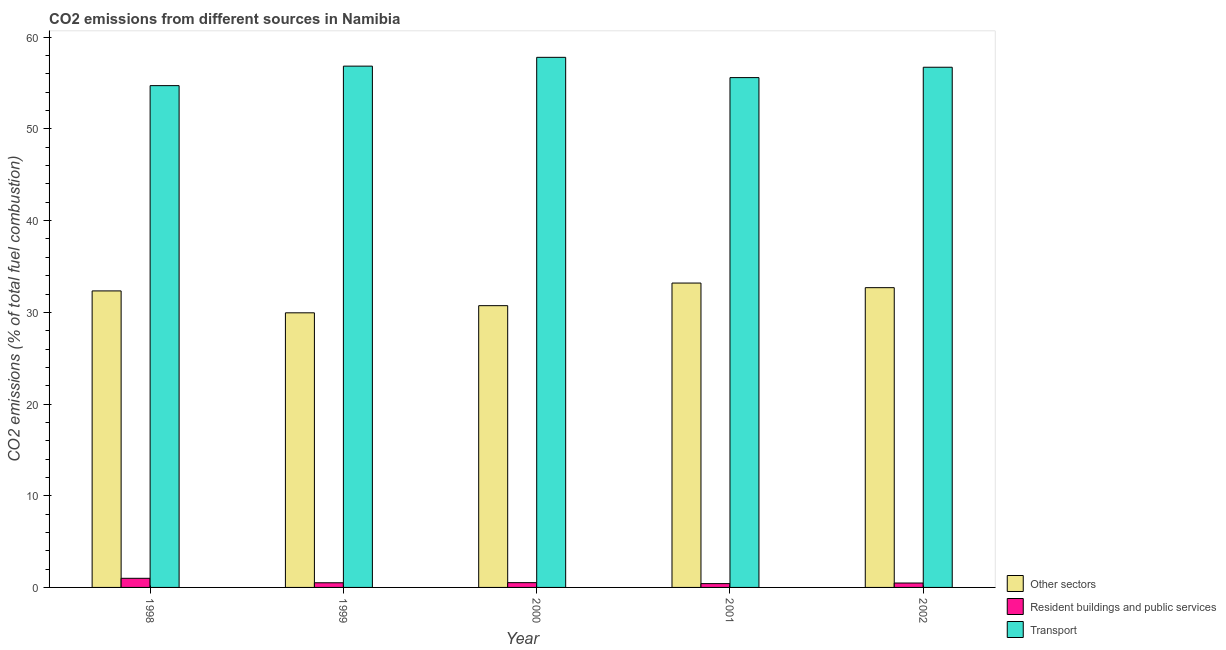How many groups of bars are there?
Provide a succinct answer. 5. Are the number of bars per tick equal to the number of legend labels?
Offer a very short reply. Yes. Are the number of bars on each tick of the X-axis equal?
Your answer should be compact. Yes. How many bars are there on the 2nd tick from the left?
Offer a very short reply. 3. What is the label of the 3rd group of bars from the left?
Your response must be concise. 2000. In how many cases, is the number of bars for a given year not equal to the number of legend labels?
Ensure brevity in your answer.  0. What is the percentage of co2 emissions from transport in 2001?
Keep it short and to the point. 55.6. Across all years, what is the maximum percentage of co2 emissions from transport?
Ensure brevity in your answer.  57.81. Across all years, what is the minimum percentage of co2 emissions from transport?
Give a very brief answer. 54.73. What is the total percentage of co2 emissions from transport in the graph?
Provide a succinct answer. 281.72. What is the difference between the percentage of co2 emissions from resident buildings and public services in 2001 and that in 2002?
Your answer should be compact. -0.07. What is the difference between the percentage of co2 emissions from transport in 1999 and the percentage of co2 emissions from other sectors in 1998?
Provide a short and direct response. 2.13. What is the average percentage of co2 emissions from other sectors per year?
Make the answer very short. 31.78. In how many years, is the percentage of co2 emissions from other sectors greater than 28 %?
Provide a short and direct response. 5. What is the ratio of the percentage of co2 emissions from resident buildings and public services in 2000 to that in 2002?
Make the answer very short. 1.08. Is the difference between the percentage of co2 emissions from resident buildings and public services in 1999 and 2000 greater than the difference between the percentage of co2 emissions from other sectors in 1999 and 2000?
Make the answer very short. No. What is the difference between the highest and the second highest percentage of co2 emissions from other sectors?
Ensure brevity in your answer.  0.5. What is the difference between the highest and the lowest percentage of co2 emissions from transport?
Make the answer very short. 3.09. In how many years, is the percentage of co2 emissions from other sectors greater than the average percentage of co2 emissions from other sectors taken over all years?
Keep it short and to the point. 3. Is the sum of the percentage of co2 emissions from resident buildings and public services in 1998 and 1999 greater than the maximum percentage of co2 emissions from transport across all years?
Keep it short and to the point. Yes. What does the 3rd bar from the left in 2002 represents?
Provide a succinct answer. Transport. What does the 3rd bar from the right in 2002 represents?
Provide a short and direct response. Other sectors. How many bars are there?
Your answer should be very brief. 15. Are the values on the major ticks of Y-axis written in scientific E-notation?
Provide a short and direct response. No. What is the title of the graph?
Give a very brief answer. CO2 emissions from different sources in Namibia. What is the label or title of the Y-axis?
Ensure brevity in your answer.  CO2 emissions (% of total fuel combustion). What is the CO2 emissions (% of total fuel combustion) in Other sectors in 1998?
Your answer should be very brief. 32.34. What is the CO2 emissions (% of total fuel combustion) in Resident buildings and public services in 1998?
Give a very brief answer. 1. What is the CO2 emissions (% of total fuel combustion) of Transport in 1998?
Ensure brevity in your answer.  54.73. What is the CO2 emissions (% of total fuel combustion) in Other sectors in 1999?
Provide a succinct answer. 29.95. What is the CO2 emissions (% of total fuel combustion) of Resident buildings and public services in 1999?
Offer a terse response. 0.51. What is the CO2 emissions (% of total fuel combustion) in Transport in 1999?
Give a very brief answer. 56.85. What is the CO2 emissions (% of total fuel combustion) in Other sectors in 2000?
Offer a terse response. 30.73. What is the CO2 emissions (% of total fuel combustion) in Resident buildings and public services in 2000?
Your answer should be compact. 0.52. What is the CO2 emissions (% of total fuel combustion) of Transport in 2000?
Keep it short and to the point. 57.81. What is the CO2 emissions (% of total fuel combustion) of Other sectors in 2001?
Give a very brief answer. 33.2. What is the CO2 emissions (% of total fuel combustion) of Resident buildings and public services in 2001?
Offer a terse response. 0.41. What is the CO2 emissions (% of total fuel combustion) in Transport in 2001?
Make the answer very short. 55.6. What is the CO2 emissions (% of total fuel combustion) in Other sectors in 2002?
Offer a very short reply. 32.69. What is the CO2 emissions (% of total fuel combustion) in Resident buildings and public services in 2002?
Your answer should be very brief. 0.48. What is the CO2 emissions (% of total fuel combustion) in Transport in 2002?
Make the answer very short. 56.73. Across all years, what is the maximum CO2 emissions (% of total fuel combustion) of Other sectors?
Offer a terse response. 33.2. Across all years, what is the maximum CO2 emissions (% of total fuel combustion) in Resident buildings and public services?
Ensure brevity in your answer.  1. Across all years, what is the maximum CO2 emissions (% of total fuel combustion) of Transport?
Your response must be concise. 57.81. Across all years, what is the minimum CO2 emissions (% of total fuel combustion) in Other sectors?
Your response must be concise. 29.95. Across all years, what is the minimum CO2 emissions (% of total fuel combustion) in Resident buildings and public services?
Your response must be concise. 0.41. Across all years, what is the minimum CO2 emissions (% of total fuel combustion) in Transport?
Offer a very short reply. 54.73. What is the total CO2 emissions (% of total fuel combustion) in Other sectors in the graph?
Your answer should be very brief. 158.9. What is the total CO2 emissions (% of total fuel combustion) in Resident buildings and public services in the graph?
Provide a short and direct response. 2.92. What is the total CO2 emissions (% of total fuel combustion) of Transport in the graph?
Your answer should be very brief. 281.72. What is the difference between the CO2 emissions (% of total fuel combustion) of Other sectors in 1998 and that in 1999?
Offer a very short reply. 2.39. What is the difference between the CO2 emissions (% of total fuel combustion) of Resident buildings and public services in 1998 and that in 1999?
Your answer should be compact. 0.49. What is the difference between the CO2 emissions (% of total fuel combustion) in Transport in 1998 and that in 1999?
Keep it short and to the point. -2.13. What is the difference between the CO2 emissions (% of total fuel combustion) of Other sectors in 1998 and that in 2000?
Offer a terse response. 1.61. What is the difference between the CO2 emissions (% of total fuel combustion) in Resident buildings and public services in 1998 and that in 2000?
Your answer should be compact. 0.47. What is the difference between the CO2 emissions (% of total fuel combustion) in Transport in 1998 and that in 2000?
Provide a succinct answer. -3.09. What is the difference between the CO2 emissions (% of total fuel combustion) of Other sectors in 1998 and that in 2001?
Offer a terse response. -0.86. What is the difference between the CO2 emissions (% of total fuel combustion) in Resident buildings and public services in 1998 and that in 2001?
Provide a short and direct response. 0.58. What is the difference between the CO2 emissions (% of total fuel combustion) in Transport in 1998 and that in 2001?
Provide a succinct answer. -0.88. What is the difference between the CO2 emissions (% of total fuel combustion) in Other sectors in 1998 and that in 2002?
Your answer should be compact. -0.35. What is the difference between the CO2 emissions (% of total fuel combustion) in Resident buildings and public services in 1998 and that in 2002?
Your answer should be very brief. 0.51. What is the difference between the CO2 emissions (% of total fuel combustion) in Transport in 1998 and that in 2002?
Your response must be concise. -2. What is the difference between the CO2 emissions (% of total fuel combustion) in Other sectors in 1999 and that in 2000?
Keep it short and to the point. -0.78. What is the difference between the CO2 emissions (% of total fuel combustion) in Resident buildings and public services in 1999 and that in 2000?
Provide a short and direct response. -0.01. What is the difference between the CO2 emissions (% of total fuel combustion) in Transport in 1999 and that in 2000?
Provide a succinct answer. -0.96. What is the difference between the CO2 emissions (% of total fuel combustion) of Other sectors in 1999 and that in 2001?
Make the answer very short. -3.25. What is the difference between the CO2 emissions (% of total fuel combustion) in Resident buildings and public services in 1999 and that in 2001?
Provide a short and direct response. 0.09. What is the difference between the CO2 emissions (% of total fuel combustion) of Transport in 1999 and that in 2001?
Provide a succinct answer. 1.25. What is the difference between the CO2 emissions (% of total fuel combustion) of Other sectors in 1999 and that in 2002?
Ensure brevity in your answer.  -2.74. What is the difference between the CO2 emissions (% of total fuel combustion) in Resident buildings and public services in 1999 and that in 2002?
Provide a succinct answer. 0.03. What is the difference between the CO2 emissions (% of total fuel combustion) of Transport in 1999 and that in 2002?
Give a very brief answer. 0.12. What is the difference between the CO2 emissions (% of total fuel combustion) in Other sectors in 2000 and that in 2001?
Ensure brevity in your answer.  -2.47. What is the difference between the CO2 emissions (% of total fuel combustion) in Resident buildings and public services in 2000 and that in 2001?
Keep it short and to the point. 0.11. What is the difference between the CO2 emissions (% of total fuel combustion) in Transport in 2000 and that in 2001?
Provide a short and direct response. 2.21. What is the difference between the CO2 emissions (% of total fuel combustion) in Other sectors in 2000 and that in 2002?
Your answer should be very brief. -1.96. What is the difference between the CO2 emissions (% of total fuel combustion) in Resident buildings and public services in 2000 and that in 2002?
Offer a terse response. 0.04. What is the difference between the CO2 emissions (% of total fuel combustion) in Transport in 2000 and that in 2002?
Ensure brevity in your answer.  1.08. What is the difference between the CO2 emissions (% of total fuel combustion) of Other sectors in 2001 and that in 2002?
Provide a succinct answer. 0.5. What is the difference between the CO2 emissions (% of total fuel combustion) in Resident buildings and public services in 2001 and that in 2002?
Give a very brief answer. -0.07. What is the difference between the CO2 emissions (% of total fuel combustion) in Transport in 2001 and that in 2002?
Ensure brevity in your answer.  -1.13. What is the difference between the CO2 emissions (% of total fuel combustion) of Other sectors in 1998 and the CO2 emissions (% of total fuel combustion) of Resident buildings and public services in 1999?
Your answer should be compact. 31.83. What is the difference between the CO2 emissions (% of total fuel combustion) of Other sectors in 1998 and the CO2 emissions (% of total fuel combustion) of Transport in 1999?
Your answer should be compact. -24.51. What is the difference between the CO2 emissions (% of total fuel combustion) in Resident buildings and public services in 1998 and the CO2 emissions (% of total fuel combustion) in Transport in 1999?
Provide a short and direct response. -55.86. What is the difference between the CO2 emissions (% of total fuel combustion) of Other sectors in 1998 and the CO2 emissions (% of total fuel combustion) of Resident buildings and public services in 2000?
Give a very brief answer. 31.82. What is the difference between the CO2 emissions (% of total fuel combustion) of Other sectors in 1998 and the CO2 emissions (% of total fuel combustion) of Transport in 2000?
Provide a short and direct response. -25.47. What is the difference between the CO2 emissions (% of total fuel combustion) in Resident buildings and public services in 1998 and the CO2 emissions (% of total fuel combustion) in Transport in 2000?
Your answer should be compact. -56.82. What is the difference between the CO2 emissions (% of total fuel combustion) of Other sectors in 1998 and the CO2 emissions (% of total fuel combustion) of Resident buildings and public services in 2001?
Make the answer very short. 31.92. What is the difference between the CO2 emissions (% of total fuel combustion) in Other sectors in 1998 and the CO2 emissions (% of total fuel combustion) in Transport in 2001?
Ensure brevity in your answer.  -23.26. What is the difference between the CO2 emissions (% of total fuel combustion) in Resident buildings and public services in 1998 and the CO2 emissions (% of total fuel combustion) in Transport in 2001?
Give a very brief answer. -54.61. What is the difference between the CO2 emissions (% of total fuel combustion) in Other sectors in 1998 and the CO2 emissions (% of total fuel combustion) in Resident buildings and public services in 2002?
Offer a very short reply. 31.86. What is the difference between the CO2 emissions (% of total fuel combustion) in Other sectors in 1998 and the CO2 emissions (% of total fuel combustion) in Transport in 2002?
Offer a very short reply. -24.39. What is the difference between the CO2 emissions (% of total fuel combustion) in Resident buildings and public services in 1998 and the CO2 emissions (% of total fuel combustion) in Transport in 2002?
Ensure brevity in your answer.  -55.74. What is the difference between the CO2 emissions (% of total fuel combustion) of Other sectors in 1999 and the CO2 emissions (% of total fuel combustion) of Resident buildings and public services in 2000?
Your response must be concise. 29.43. What is the difference between the CO2 emissions (% of total fuel combustion) of Other sectors in 1999 and the CO2 emissions (% of total fuel combustion) of Transport in 2000?
Your response must be concise. -27.86. What is the difference between the CO2 emissions (% of total fuel combustion) in Resident buildings and public services in 1999 and the CO2 emissions (% of total fuel combustion) in Transport in 2000?
Keep it short and to the point. -57.3. What is the difference between the CO2 emissions (% of total fuel combustion) in Other sectors in 1999 and the CO2 emissions (% of total fuel combustion) in Resident buildings and public services in 2001?
Provide a succinct answer. 29.53. What is the difference between the CO2 emissions (% of total fuel combustion) of Other sectors in 1999 and the CO2 emissions (% of total fuel combustion) of Transport in 2001?
Keep it short and to the point. -25.65. What is the difference between the CO2 emissions (% of total fuel combustion) in Resident buildings and public services in 1999 and the CO2 emissions (% of total fuel combustion) in Transport in 2001?
Offer a very short reply. -55.09. What is the difference between the CO2 emissions (% of total fuel combustion) of Other sectors in 1999 and the CO2 emissions (% of total fuel combustion) of Resident buildings and public services in 2002?
Offer a very short reply. 29.47. What is the difference between the CO2 emissions (% of total fuel combustion) in Other sectors in 1999 and the CO2 emissions (% of total fuel combustion) in Transport in 2002?
Offer a very short reply. -26.78. What is the difference between the CO2 emissions (% of total fuel combustion) in Resident buildings and public services in 1999 and the CO2 emissions (% of total fuel combustion) in Transport in 2002?
Your answer should be very brief. -56.22. What is the difference between the CO2 emissions (% of total fuel combustion) of Other sectors in 2000 and the CO2 emissions (% of total fuel combustion) of Resident buildings and public services in 2001?
Give a very brief answer. 30.31. What is the difference between the CO2 emissions (% of total fuel combustion) in Other sectors in 2000 and the CO2 emissions (% of total fuel combustion) in Transport in 2001?
Provide a succinct answer. -24.87. What is the difference between the CO2 emissions (% of total fuel combustion) of Resident buildings and public services in 2000 and the CO2 emissions (% of total fuel combustion) of Transport in 2001?
Give a very brief answer. -55.08. What is the difference between the CO2 emissions (% of total fuel combustion) of Other sectors in 2000 and the CO2 emissions (% of total fuel combustion) of Resident buildings and public services in 2002?
Give a very brief answer. 30.25. What is the difference between the CO2 emissions (% of total fuel combustion) of Other sectors in 2000 and the CO2 emissions (% of total fuel combustion) of Transport in 2002?
Ensure brevity in your answer.  -26. What is the difference between the CO2 emissions (% of total fuel combustion) in Resident buildings and public services in 2000 and the CO2 emissions (% of total fuel combustion) in Transport in 2002?
Offer a terse response. -56.21. What is the difference between the CO2 emissions (% of total fuel combustion) of Other sectors in 2001 and the CO2 emissions (% of total fuel combustion) of Resident buildings and public services in 2002?
Ensure brevity in your answer.  32.71. What is the difference between the CO2 emissions (% of total fuel combustion) in Other sectors in 2001 and the CO2 emissions (% of total fuel combustion) in Transport in 2002?
Your answer should be compact. -23.54. What is the difference between the CO2 emissions (% of total fuel combustion) of Resident buildings and public services in 2001 and the CO2 emissions (% of total fuel combustion) of Transport in 2002?
Offer a very short reply. -56.32. What is the average CO2 emissions (% of total fuel combustion) in Other sectors per year?
Give a very brief answer. 31.78. What is the average CO2 emissions (% of total fuel combustion) of Resident buildings and public services per year?
Your answer should be compact. 0.58. What is the average CO2 emissions (% of total fuel combustion) of Transport per year?
Offer a very short reply. 56.34. In the year 1998, what is the difference between the CO2 emissions (% of total fuel combustion) of Other sectors and CO2 emissions (% of total fuel combustion) of Resident buildings and public services?
Keep it short and to the point. 31.34. In the year 1998, what is the difference between the CO2 emissions (% of total fuel combustion) of Other sectors and CO2 emissions (% of total fuel combustion) of Transport?
Ensure brevity in your answer.  -22.39. In the year 1998, what is the difference between the CO2 emissions (% of total fuel combustion) of Resident buildings and public services and CO2 emissions (% of total fuel combustion) of Transport?
Give a very brief answer. -53.73. In the year 1999, what is the difference between the CO2 emissions (% of total fuel combustion) of Other sectors and CO2 emissions (% of total fuel combustion) of Resident buildings and public services?
Provide a succinct answer. 29.44. In the year 1999, what is the difference between the CO2 emissions (% of total fuel combustion) in Other sectors and CO2 emissions (% of total fuel combustion) in Transport?
Offer a very short reply. -26.9. In the year 1999, what is the difference between the CO2 emissions (% of total fuel combustion) in Resident buildings and public services and CO2 emissions (% of total fuel combustion) in Transport?
Your answer should be very brief. -56.35. In the year 2000, what is the difference between the CO2 emissions (% of total fuel combustion) in Other sectors and CO2 emissions (% of total fuel combustion) in Resident buildings and public services?
Your answer should be compact. 30.21. In the year 2000, what is the difference between the CO2 emissions (% of total fuel combustion) in Other sectors and CO2 emissions (% of total fuel combustion) in Transport?
Offer a terse response. -27.08. In the year 2000, what is the difference between the CO2 emissions (% of total fuel combustion) in Resident buildings and public services and CO2 emissions (% of total fuel combustion) in Transport?
Keep it short and to the point. -57.29. In the year 2001, what is the difference between the CO2 emissions (% of total fuel combustion) in Other sectors and CO2 emissions (% of total fuel combustion) in Resident buildings and public services?
Your response must be concise. 32.78. In the year 2001, what is the difference between the CO2 emissions (% of total fuel combustion) of Other sectors and CO2 emissions (% of total fuel combustion) of Transport?
Provide a succinct answer. -22.41. In the year 2001, what is the difference between the CO2 emissions (% of total fuel combustion) of Resident buildings and public services and CO2 emissions (% of total fuel combustion) of Transport?
Offer a terse response. -55.19. In the year 2002, what is the difference between the CO2 emissions (% of total fuel combustion) in Other sectors and CO2 emissions (% of total fuel combustion) in Resident buildings and public services?
Your response must be concise. 32.21. In the year 2002, what is the difference between the CO2 emissions (% of total fuel combustion) in Other sectors and CO2 emissions (% of total fuel combustion) in Transport?
Offer a very short reply. -24.04. In the year 2002, what is the difference between the CO2 emissions (% of total fuel combustion) of Resident buildings and public services and CO2 emissions (% of total fuel combustion) of Transport?
Provide a short and direct response. -56.25. What is the ratio of the CO2 emissions (% of total fuel combustion) in Other sectors in 1998 to that in 1999?
Ensure brevity in your answer.  1.08. What is the ratio of the CO2 emissions (% of total fuel combustion) of Resident buildings and public services in 1998 to that in 1999?
Your answer should be very brief. 1.96. What is the ratio of the CO2 emissions (% of total fuel combustion) in Transport in 1998 to that in 1999?
Provide a short and direct response. 0.96. What is the ratio of the CO2 emissions (% of total fuel combustion) of Other sectors in 1998 to that in 2000?
Offer a terse response. 1.05. What is the ratio of the CO2 emissions (% of total fuel combustion) in Resident buildings and public services in 1998 to that in 2000?
Your answer should be very brief. 1.91. What is the ratio of the CO2 emissions (% of total fuel combustion) in Transport in 1998 to that in 2000?
Make the answer very short. 0.95. What is the ratio of the CO2 emissions (% of total fuel combustion) in Other sectors in 1998 to that in 2001?
Offer a very short reply. 0.97. What is the ratio of the CO2 emissions (% of total fuel combustion) of Resident buildings and public services in 1998 to that in 2001?
Your answer should be very brief. 2.4. What is the ratio of the CO2 emissions (% of total fuel combustion) of Transport in 1998 to that in 2001?
Ensure brevity in your answer.  0.98. What is the ratio of the CO2 emissions (% of total fuel combustion) in Resident buildings and public services in 1998 to that in 2002?
Offer a very short reply. 2.07. What is the ratio of the CO2 emissions (% of total fuel combustion) in Transport in 1998 to that in 2002?
Offer a very short reply. 0.96. What is the ratio of the CO2 emissions (% of total fuel combustion) of Other sectors in 1999 to that in 2000?
Offer a very short reply. 0.97. What is the ratio of the CO2 emissions (% of total fuel combustion) of Resident buildings and public services in 1999 to that in 2000?
Your response must be concise. 0.97. What is the ratio of the CO2 emissions (% of total fuel combustion) in Transport in 1999 to that in 2000?
Your answer should be very brief. 0.98. What is the ratio of the CO2 emissions (% of total fuel combustion) in Other sectors in 1999 to that in 2001?
Your answer should be very brief. 0.9. What is the ratio of the CO2 emissions (% of total fuel combustion) of Resident buildings and public services in 1999 to that in 2001?
Provide a short and direct response. 1.22. What is the ratio of the CO2 emissions (% of total fuel combustion) of Transport in 1999 to that in 2001?
Offer a very short reply. 1.02. What is the ratio of the CO2 emissions (% of total fuel combustion) of Other sectors in 1999 to that in 2002?
Provide a succinct answer. 0.92. What is the ratio of the CO2 emissions (% of total fuel combustion) in Resident buildings and public services in 1999 to that in 2002?
Your answer should be compact. 1.06. What is the ratio of the CO2 emissions (% of total fuel combustion) of Transport in 1999 to that in 2002?
Make the answer very short. 1. What is the ratio of the CO2 emissions (% of total fuel combustion) of Other sectors in 2000 to that in 2001?
Offer a terse response. 0.93. What is the ratio of the CO2 emissions (% of total fuel combustion) of Resident buildings and public services in 2000 to that in 2001?
Provide a short and direct response. 1.26. What is the ratio of the CO2 emissions (% of total fuel combustion) of Transport in 2000 to that in 2001?
Make the answer very short. 1.04. What is the ratio of the CO2 emissions (% of total fuel combustion) in Other sectors in 2000 to that in 2002?
Give a very brief answer. 0.94. What is the ratio of the CO2 emissions (% of total fuel combustion) of Transport in 2000 to that in 2002?
Provide a short and direct response. 1.02. What is the ratio of the CO2 emissions (% of total fuel combustion) of Other sectors in 2001 to that in 2002?
Your answer should be very brief. 1.02. What is the ratio of the CO2 emissions (% of total fuel combustion) of Resident buildings and public services in 2001 to that in 2002?
Your answer should be very brief. 0.86. What is the ratio of the CO2 emissions (% of total fuel combustion) of Transport in 2001 to that in 2002?
Ensure brevity in your answer.  0.98. What is the difference between the highest and the second highest CO2 emissions (% of total fuel combustion) of Other sectors?
Ensure brevity in your answer.  0.5. What is the difference between the highest and the second highest CO2 emissions (% of total fuel combustion) of Resident buildings and public services?
Make the answer very short. 0.47. What is the difference between the highest and the second highest CO2 emissions (% of total fuel combustion) of Transport?
Keep it short and to the point. 0.96. What is the difference between the highest and the lowest CO2 emissions (% of total fuel combustion) in Other sectors?
Provide a succinct answer. 3.25. What is the difference between the highest and the lowest CO2 emissions (% of total fuel combustion) in Resident buildings and public services?
Your answer should be compact. 0.58. What is the difference between the highest and the lowest CO2 emissions (% of total fuel combustion) of Transport?
Provide a succinct answer. 3.09. 